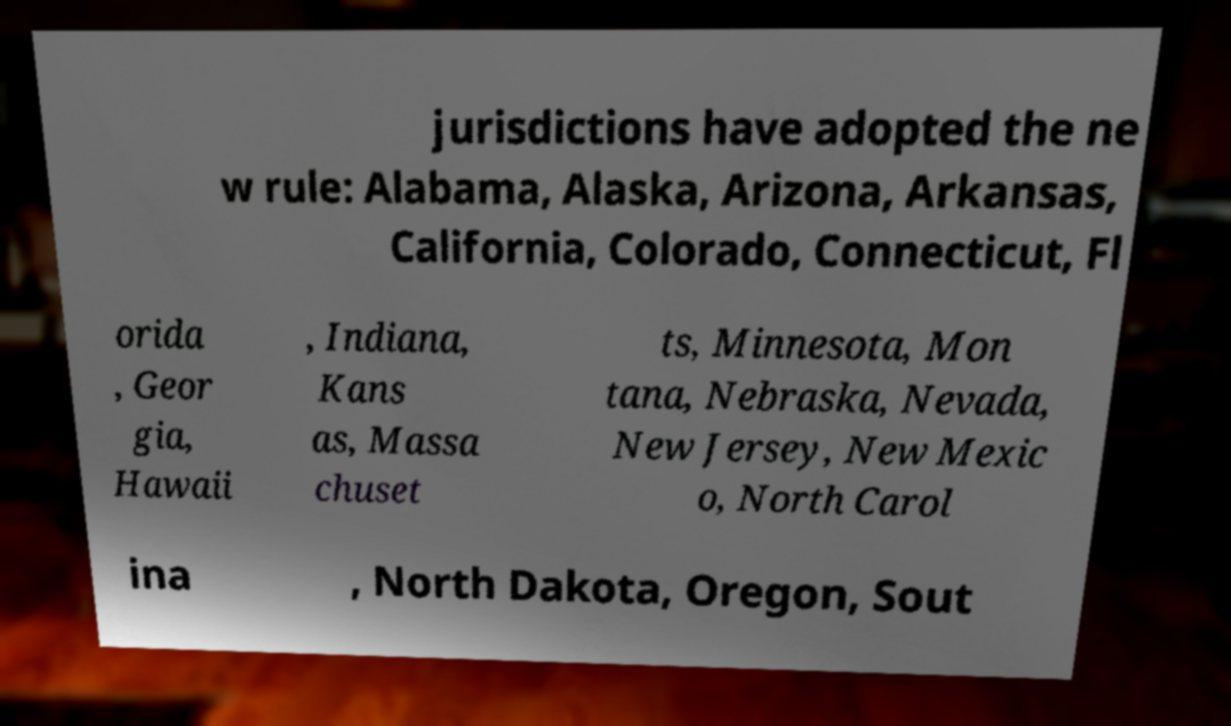Please identify and transcribe the text found in this image. jurisdictions have adopted the ne w rule: Alabama, Alaska, Arizona, Arkansas, California, Colorado, Connecticut, Fl orida , Geor gia, Hawaii , Indiana, Kans as, Massa chuset ts, Minnesota, Mon tana, Nebraska, Nevada, New Jersey, New Mexic o, North Carol ina , North Dakota, Oregon, Sout 